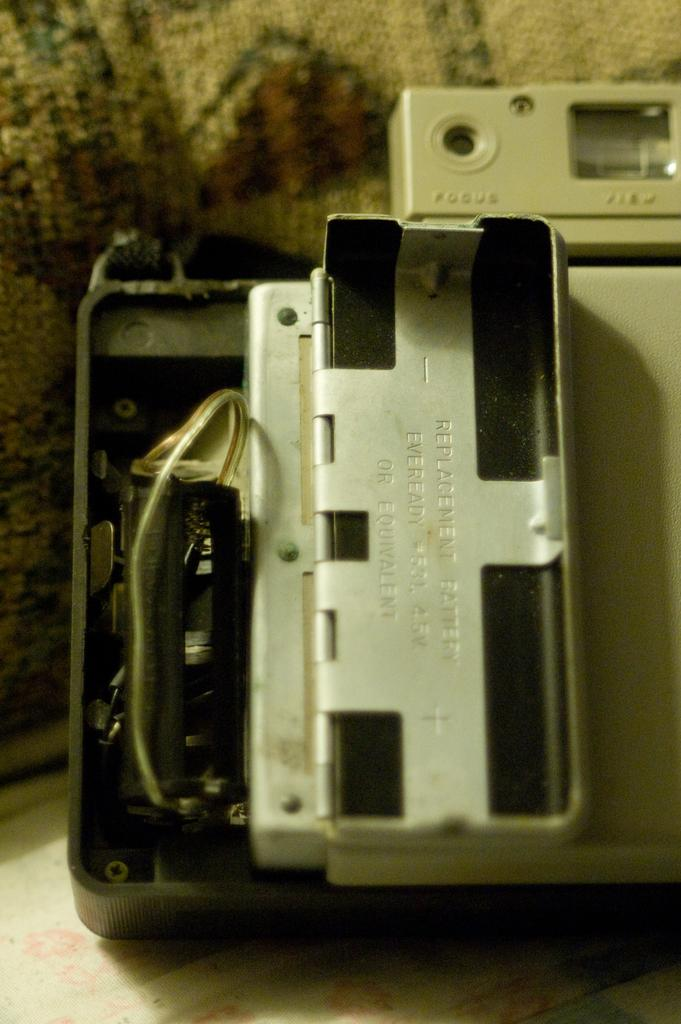What part of a camera can be seen in the image? The backside of a camera is visible in the image. What additional information can be gathered from the image about the camera? There is text written on or near the camera. What type of hair can be seen on the camera in the image? There is no hair present on the camera in the image. What kind of pump is attached to the camera in the image? There is no pump present on the camera in the image. 